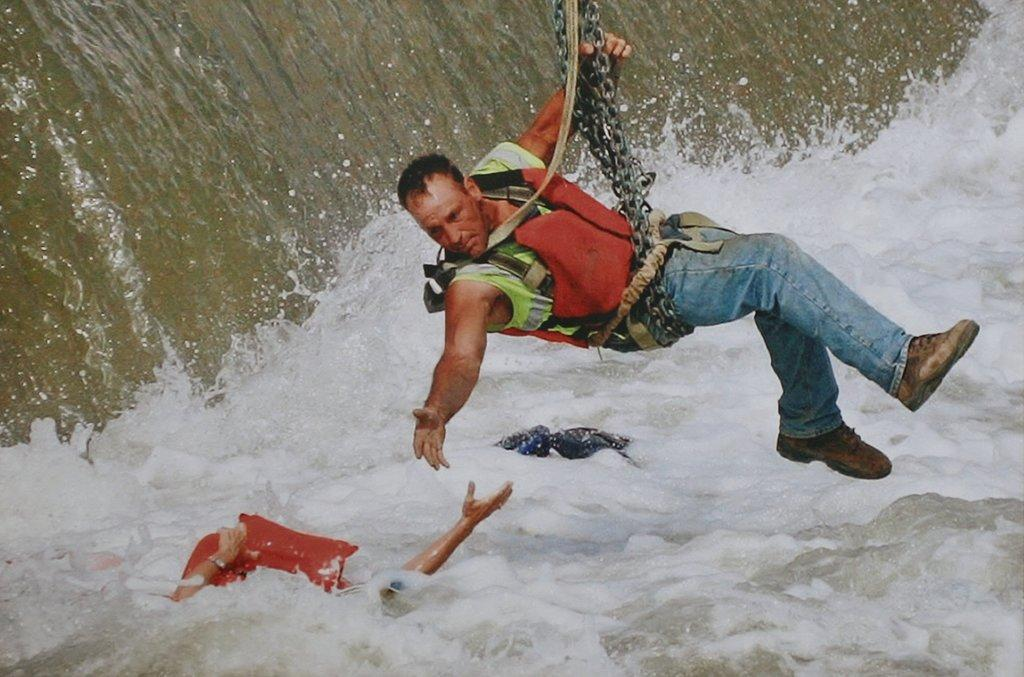What is the main subject of the image? The main subject of the image is a person in the water and another person in the air. Can you describe the person in the air? The person in the air is attached to chains. What is the position of the person in the water in relation to the person in the air? The person in the water is below the person in the air. What type of bit is the fireman using to put out the fire in the image? There is no fire or fireman present in the image, so it is not possible to determine if a bit is being used. 